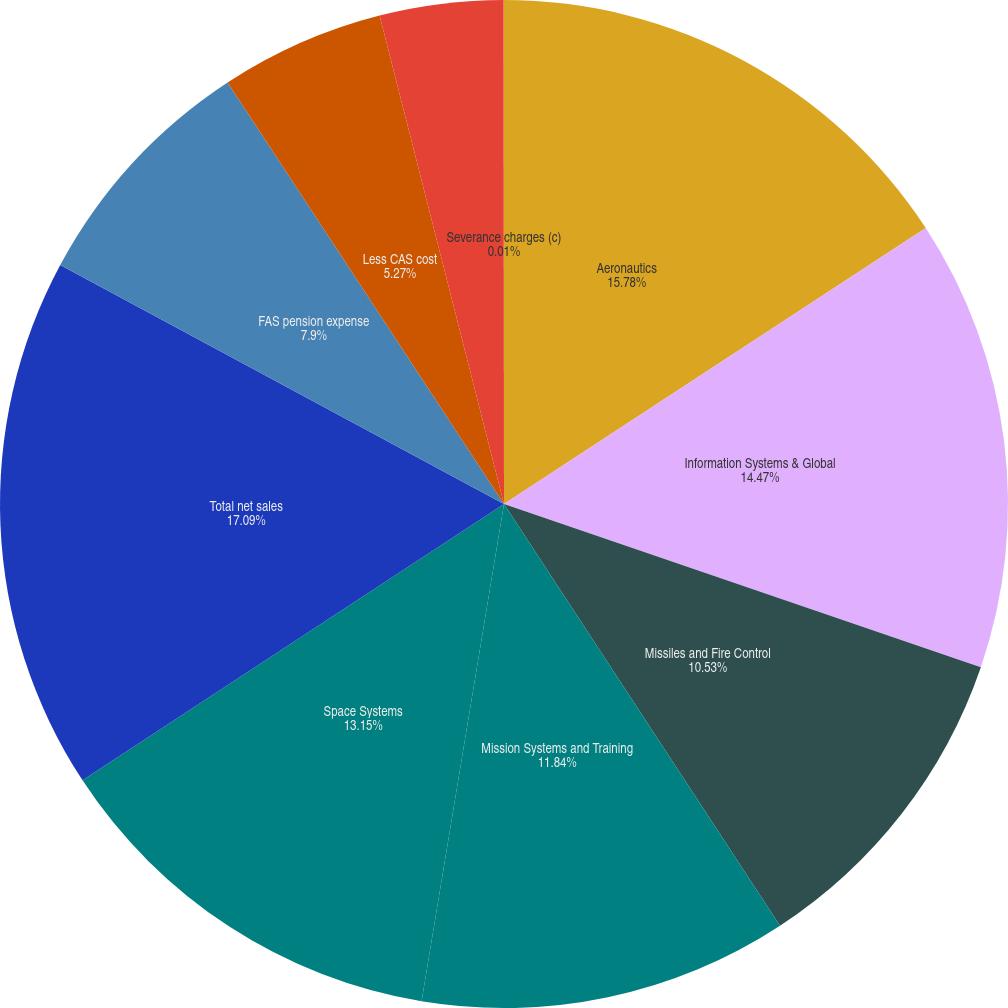<chart> <loc_0><loc_0><loc_500><loc_500><pie_chart><fcel>Aeronautics<fcel>Information Systems & Global<fcel>Missiles and Fire Control<fcel>Mission Systems and Training<fcel>Space Systems<fcel>Total net sales<fcel>FAS pension expense<fcel>Less CAS cost<fcel>FAS/CAS pension expense (a)<fcel>Severance charges (c)<nl><fcel>15.78%<fcel>14.47%<fcel>10.53%<fcel>11.84%<fcel>13.15%<fcel>17.1%<fcel>7.9%<fcel>5.27%<fcel>3.96%<fcel>0.01%<nl></chart> 